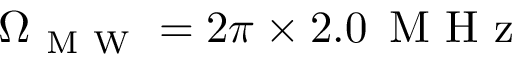<formula> <loc_0><loc_0><loc_500><loc_500>\Omega _ { M W } = 2 \pi \times 2 . 0 \, M H z</formula> 